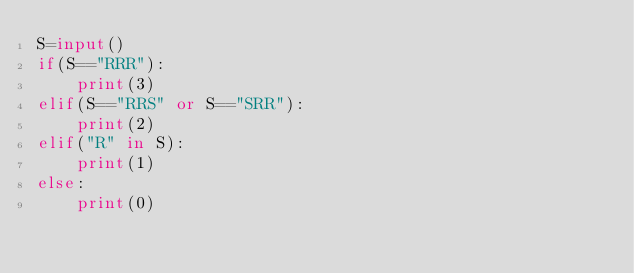<code> <loc_0><loc_0><loc_500><loc_500><_Python_>S=input()
if(S=="RRR"):
    print(3)
elif(S=="RRS" or S=="SRR"):
    print(2)
elif("R" in S):
    print(1)
else:
    print(0)</code> 